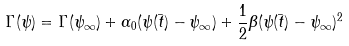Convert formula to latex. <formula><loc_0><loc_0><loc_500><loc_500>\Gamma ( \psi ) = \Gamma ( \psi _ { \infty } ) + \alpha _ { 0 } ( \psi ( \bar { t } ) - \psi _ { \infty } ) + \frac { 1 } { 2 } \beta ( \psi ( \bar { t } ) - \psi _ { \infty } ) ^ { 2 }</formula> 